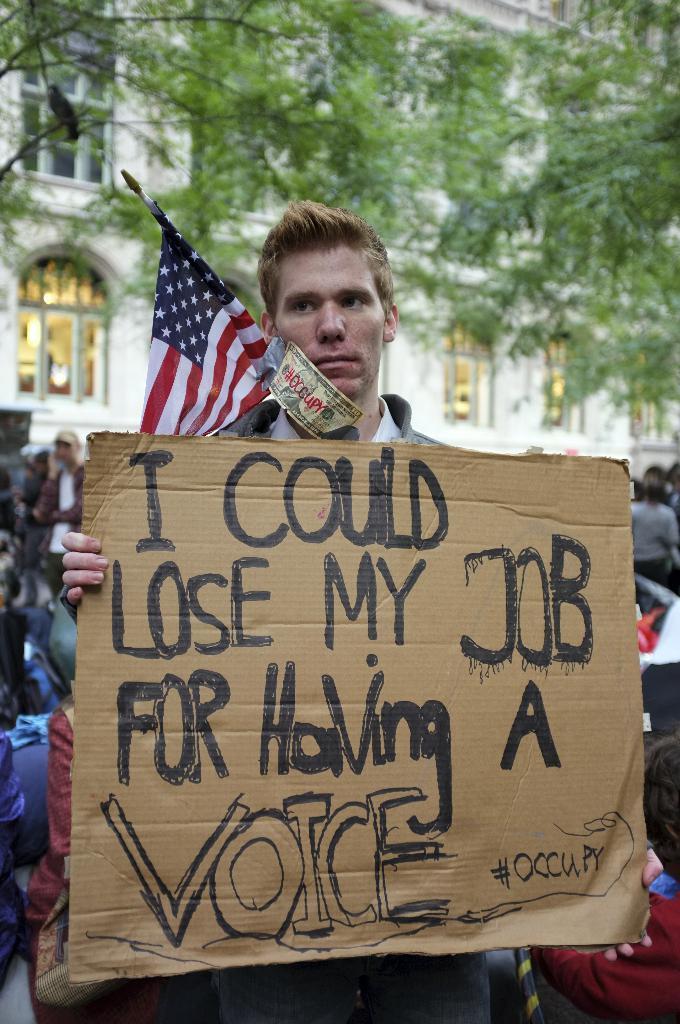Could you give a brief overview of what you see in this image? In this picture we can see group of people, in the middle of the image we can see a man, he is holding a cardboard and we can find some text on it, behind him we can see a flag, in the background we can see few trees and a building. 